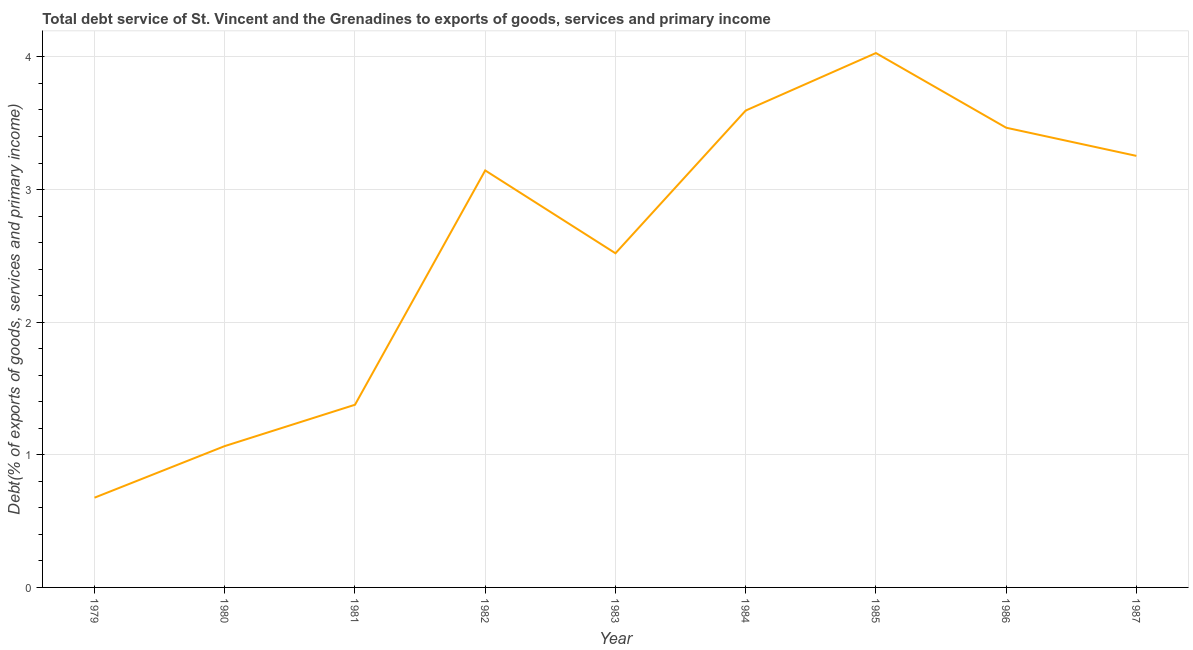What is the total debt service in 1987?
Offer a very short reply. 3.25. Across all years, what is the maximum total debt service?
Give a very brief answer. 4.03. Across all years, what is the minimum total debt service?
Your response must be concise. 0.68. In which year was the total debt service minimum?
Your answer should be compact. 1979. What is the sum of the total debt service?
Provide a succinct answer. 23.13. What is the difference between the total debt service in 1979 and 1986?
Your answer should be very brief. -2.79. What is the average total debt service per year?
Ensure brevity in your answer.  2.57. What is the median total debt service?
Keep it short and to the point. 3.14. What is the ratio of the total debt service in 1979 to that in 1984?
Make the answer very short. 0.19. What is the difference between the highest and the second highest total debt service?
Give a very brief answer. 0.43. What is the difference between the highest and the lowest total debt service?
Your answer should be compact. 3.35. How many years are there in the graph?
Your response must be concise. 9. Does the graph contain any zero values?
Keep it short and to the point. No. What is the title of the graph?
Provide a short and direct response. Total debt service of St. Vincent and the Grenadines to exports of goods, services and primary income. What is the label or title of the X-axis?
Make the answer very short. Year. What is the label or title of the Y-axis?
Offer a very short reply. Debt(% of exports of goods, services and primary income). What is the Debt(% of exports of goods, services and primary income) of 1979?
Provide a succinct answer. 0.68. What is the Debt(% of exports of goods, services and primary income) in 1980?
Keep it short and to the point. 1.07. What is the Debt(% of exports of goods, services and primary income) of 1981?
Provide a short and direct response. 1.38. What is the Debt(% of exports of goods, services and primary income) of 1982?
Keep it short and to the point. 3.14. What is the Debt(% of exports of goods, services and primary income) in 1983?
Your answer should be very brief. 2.52. What is the Debt(% of exports of goods, services and primary income) of 1984?
Your answer should be compact. 3.6. What is the Debt(% of exports of goods, services and primary income) in 1985?
Ensure brevity in your answer.  4.03. What is the Debt(% of exports of goods, services and primary income) of 1986?
Provide a succinct answer. 3.47. What is the Debt(% of exports of goods, services and primary income) in 1987?
Give a very brief answer. 3.25. What is the difference between the Debt(% of exports of goods, services and primary income) in 1979 and 1980?
Your answer should be very brief. -0.39. What is the difference between the Debt(% of exports of goods, services and primary income) in 1979 and 1981?
Keep it short and to the point. -0.7. What is the difference between the Debt(% of exports of goods, services and primary income) in 1979 and 1982?
Offer a terse response. -2.47. What is the difference between the Debt(% of exports of goods, services and primary income) in 1979 and 1983?
Keep it short and to the point. -1.84. What is the difference between the Debt(% of exports of goods, services and primary income) in 1979 and 1984?
Offer a terse response. -2.92. What is the difference between the Debt(% of exports of goods, services and primary income) in 1979 and 1985?
Offer a very short reply. -3.35. What is the difference between the Debt(% of exports of goods, services and primary income) in 1979 and 1986?
Your answer should be compact. -2.79. What is the difference between the Debt(% of exports of goods, services and primary income) in 1979 and 1987?
Your response must be concise. -2.58. What is the difference between the Debt(% of exports of goods, services and primary income) in 1980 and 1981?
Provide a succinct answer. -0.31. What is the difference between the Debt(% of exports of goods, services and primary income) in 1980 and 1982?
Provide a succinct answer. -2.08. What is the difference between the Debt(% of exports of goods, services and primary income) in 1980 and 1983?
Offer a very short reply. -1.45. What is the difference between the Debt(% of exports of goods, services and primary income) in 1980 and 1984?
Your response must be concise. -2.53. What is the difference between the Debt(% of exports of goods, services and primary income) in 1980 and 1985?
Give a very brief answer. -2.96. What is the difference between the Debt(% of exports of goods, services and primary income) in 1980 and 1986?
Offer a very short reply. -2.4. What is the difference between the Debt(% of exports of goods, services and primary income) in 1980 and 1987?
Give a very brief answer. -2.19. What is the difference between the Debt(% of exports of goods, services and primary income) in 1981 and 1982?
Give a very brief answer. -1.77. What is the difference between the Debt(% of exports of goods, services and primary income) in 1981 and 1983?
Offer a very short reply. -1.14. What is the difference between the Debt(% of exports of goods, services and primary income) in 1981 and 1984?
Your response must be concise. -2.22. What is the difference between the Debt(% of exports of goods, services and primary income) in 1981 and 1985?
Your answer should be very brief. -2.65. What is the difference between the Debt(% of exports of goods, services and primary income) in 1981 and 1986?
Your response must be concise. -2.09. What is the difference between the Debt(% of exports of goods, services and primary income) in 1981 and 1987?
Your response must be concise. -1.88. What is the difference between the Debt(% of exports of goods, services and primary income) in 1982 and 1983?
Keep it short and to the point. 0.62. What is the difference between the Debt(% of exports of goods, services and primary income) in 1982 and 1984?
Offer a terse response. -0.45. What is the difference between the Debt(% of exports of goods, services and primary income) in 1982 and 1985?
Your answer should be compact. -0.88. What is the difference between the Debt(% of exports of goods, services and primary income) in 1982 and 1986?
Your response must be concise. -0.32. What is the difference between the Debt(% of exports of goods, services and primary income) in 1982 and 1987?
Give a very brief answer. -0.11. What is the difference between the Debt(% of exports of goods, services and primary income) in 1983 and 1984?
Give a very brief answer. -1.08. What is the difference between the Debt(% of exports of goods, services and primary income) in 1983 and 1985?
Provide a short and direct response. -1.51. What is the difference between the Debt(% of exports of goods, services and primary income) in 1983 and 1986?
Provide a succinct answer. -0.95. What is the difference between the Debt(% of exports of goods, services and primary income) in 1983 and 1987?
Ensure brevity in your answer.  -0.73. What is the difference between the Debt(% of exports of goods, services and primary income) in 1984 and 1985?
Provide a succinct answer. -0.43. What is the difference between the Debt(% of exports of goods, services and primary income) in 1984 and 1986?
Provide a succinct answer. 0.13. What is the difference between the Debt(% of exports of goods, services and primary income) in 1984 and 1987?
Your response must be concise. 0.34. What is the difference between the Debt(% of exports of goods, services and primary income) in 1985 and 1986?
Your answer should be very brief. 0.56. What is the difference between the Debt(% of exports of goods, services and primary income) in 1985 and 1987?
Make the answer very short. 0.78. What is the difference between the Debt(% of exports of goods, services and primary income) in 1986 and 1987?
Offer a terse response. 0.21. What is the ratio of the Debt(% of exports of goods, services and primary income) in 1979 to that in 1980?
Give a very brief answer. 0.64. What is the ratio of the Debt(% of exports of goods, services and primary income) in 1979 to that in 1981?
Offer a terse response. 0.49. What is the ratio of the Debt(% of exports of goods, services and primary income) in 1979 to that in 1982?
Give a very brief answer. 0.21. What is the ratio of the Debt(% of exports of goods, services and primary income) in 1979 to that in 1983?
Your answer should be compact. 0.27. What is the ratio of the Debt(% of exports of goods, services and primary income) in 1979 to that in 1984?
Keep it short and to the point. 0.19. What is the ratio of the Debt(% of exports of goods, services and primary income) in 1979 to that in 1985?
Make the answer very short. 0.17. What is the ratio of the Debt(% of exports of goods, services and primary income) in 1979 to that in 1986?
Your response must be concise. 0.2. What is the ratio of the Debt(% of exports of goods, services and primary income) in 1979 to that in 1987?
Keep it short and to the point. 0.21. What is the ratio of the Debt(% of exports of goods, services and primary income) in 1980 to that in 1981?
Keep it short and to the point. 0.77. What is the ratio of the Debt(% of exports of goods, services and primary income) in 1980 to that in 1982?
Offer a very short reply. 0.34. What is the ratio of the Debt(% of exports of goods, services and primary income) in 1980 to that in 1983?
Offer a very short reply. 0.42. What is the ratio of the Debt(% of exports of goods, services and primary income) in 1980 to that in 1984?
Ensure brevity in your answer.  0.3. What is the ratio of the Debt(% of exports of goods, services and primary income) in 1980 to that in 1985?
Give a very brief answer. 0.26. What is the ratio of the Debt(% of exports of goods, services and primary income) in 1980 to that in 1986?
Keep it short and to the point. 0.31. What is the ratio of the Debt(% of exports of goods, services and primary income) in 1980 to that in 1987?
Offer a very short reply. 0.33. What is the ratio of the Debt(% of exports of goods, services and primary income) in 1981 to that in 1982?
Give a very brief answer. 0.44. What is the ratio of the Debt(% of exports of goods, services and primary income) in 1981 to that in 1983?
Your response must be concise. 0.55. What is the ratio of the Debt(% of exports of goods, services and primary income) in 1981 to that in 1984?
Your answer should be compact. 0.38. What is the ratio of the Debt(% of exports of goods, services and primary income) in 1981 to that in 1985?
Provide a succinct answer. 0.34. What is the ratio of the Debt(% of exports of goods, services and primary income) in 1981 to that in 1986?
Offer a very short reply. 0.4. What is the ratio of the Debt(% of exports of goods, services and primary income) in 1981 to that in 1987?
Offer a very short reply. 0.42. What is the ratio of the Debt(% of exports of goods, services and primary income) in 1982 to that in 1983?
Give a very brief answer. 1.25. What is the ratio of the Debt(% of exports of goods, services and primary income) in 1982 to that in 1984?
Your answer should be compact. 0.87. What is the ratio of the Debt(% of exports of goods, services and primary income) in 1982 to that in 1985?
Your answer should be very brief. 0.78. What is the ratio of the Debt(% of exports of goods, services and primary income) in 1982 to that in 1986?
Your answer should be very brief. 0.91. What is the ratio of the Debt(% of exports of goods, services and primary income) in 1982 to that in 1987?
Provide a short and direct response. 0.97. What is the ratio of the Debt(% of exports of goods, services and primary income) in 1983 to that in 1984?
Your response must be concise. 0.7. What is the ratio of the Debt(% of exports of goods, services and primary income) in 1983 to that in 1986?
Provide a succinct answer. 0.73. What is the ratio of the Debt(% of exports of goods, services and primary income) in 1983 to that in 1987?
Provide a succinct answer. 0.77. What is the ratio of the Debt(% of exports of goods, services and primary income) in 1984 to that in 1985?
Give a very brief answer. 0.89. What is the ratio of the Debt(% of exports of goods, services and primary income) in 1984 to that in 1987?
Give a very brief answer. 1.1. What is the ratio of the Debt(% of exports of goods, services and primary income) in 1985 to that in 1986?
Provide a short and direct response. 1.16. What is the ratio of the Debt(% of exports of goods, services and primary income) in 1985 to that in 1987?
Give a very brief answer. 1.24. What is the ratio of the Debt(% of exports of goods, services and primary income) in 1986 to that in 1987?
Provide a short and direct response. 1.06. 